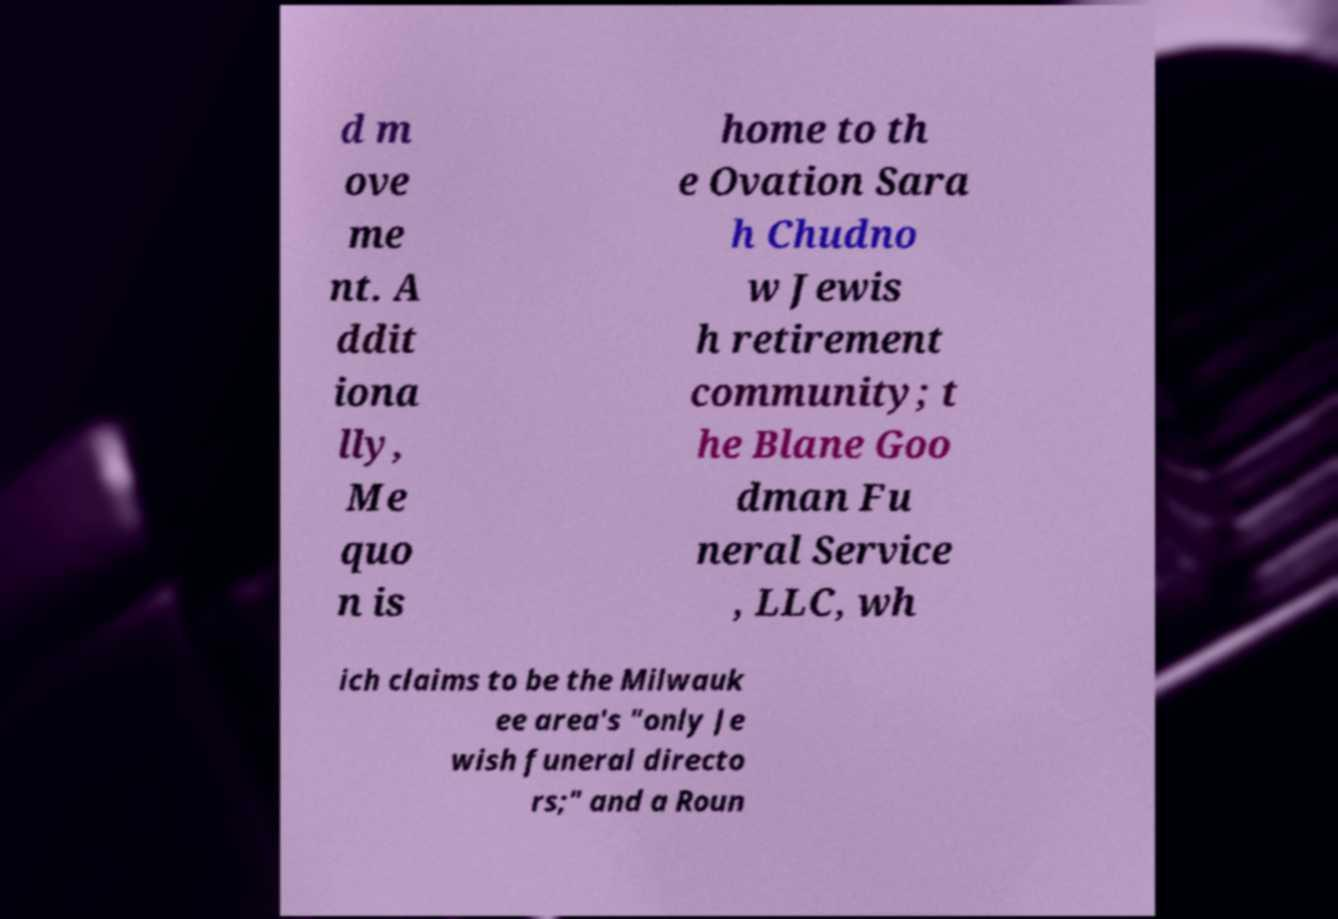Could you extract and type out the text from this image? d m ove me nt. A ddit iona lly, Me quo n is home to th e Ovation Sara h Chudno w Jewis h retirement community; t he Blane Goo dman Fu neral Service , LLC, wh ich claims to be the Milwauk ee area's "only Je wish funeral directo rs;" and a Roun 